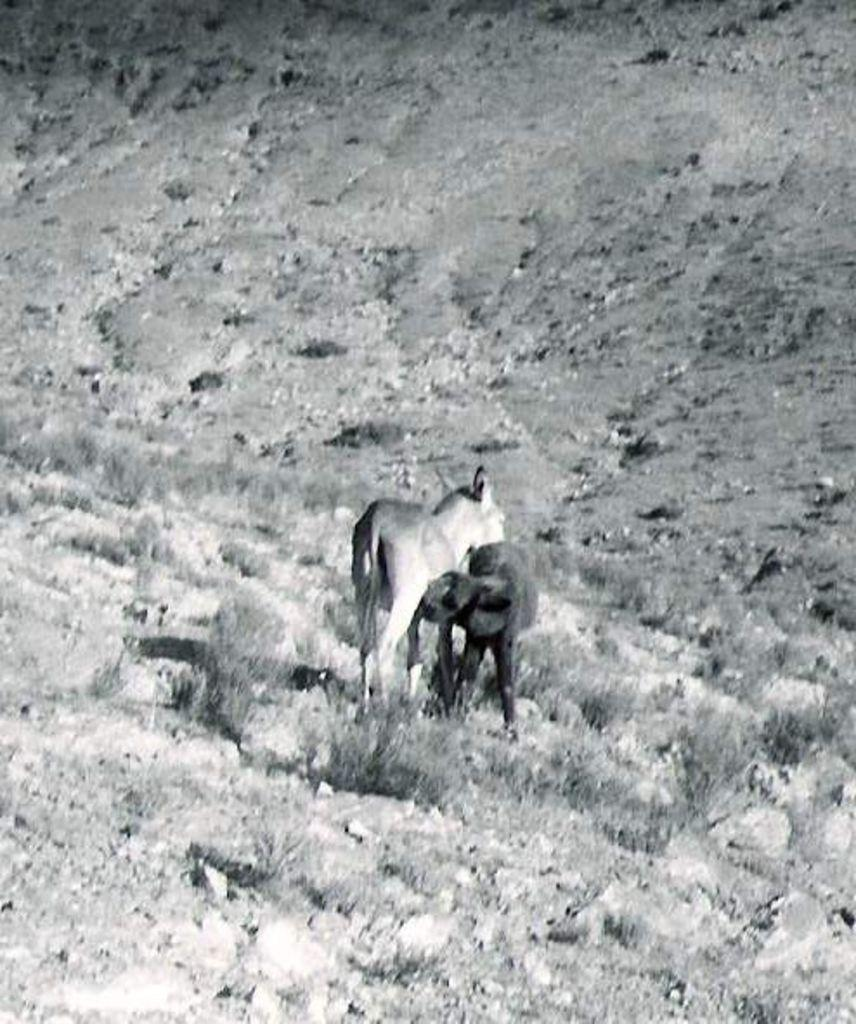What types of living organisms can be seen in the image? There are two animals in the image. What type of vegetation is visible in the image? There is grass in the image. How is the image presented in terms of color? The image is in black and white mode. How many eggs are visible in the image? There are no eggs present in the image. What type of cover is protecting the animals in the image? There is no cover present in the image; the animals are not protected by any cover. 